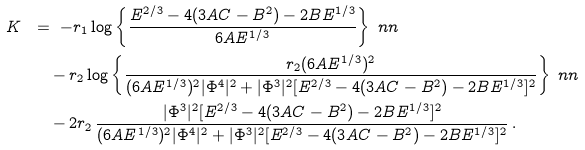<formula> <loc_0><loc_0><loc_500><loc_500>K \ & = \ - r _ { 1 } \log \left \{ \frac { E ^ { 2 / 3 } - 4 ( 3 A C - B ^ { 2 } ) - 2 B E ^ { 1 / 3 } } { 6 A E ^ { 1 / 3 } } \right \} \ n n \\ \ & \quad - r _ { 2 } \log \left \{ \frac { r _ { 2 } ( 6 A E ^ { 1 / 3 } ) ^ { 2 } } { ( 6 A E ^ { 1 / 3 } ) ^ { 2 } | \Phi ^ { 4 } | ^ { 2 } + | \Phi ^ { 3 } | ^ { 2 } [ E ^ { 2 / 3 } - 4 ( 3 A C - B ^ { 2 } ) - 2 B E ^ { 1 / 3 } ] ^ { 2 } } \right \} \ n n \\ \ & \quad - 2 r _ { 2 } \, \frac { | \Phi ^ { 3 } | ^ { 2 } [ E ^ { 2 / 3 } - 4 ( 3 A C - B ^ { 2 } ) - 2 B E ^ { 1 / 3 } ] ^ { 2 } } { ( 6 A E ^ { 1 / 3 } ) ^ { 2 } | \Phi ^ { 4 } | ^ { 2 } + | \Phi ^ { 3 } | ^ { 2 } [ E ^ { 2 / 3 } - 4 ( 3 A C - B ^ { 2 } ) - 2 B E ^ { 1 / 3 } ] ^ { 2 } } \, .</formula> 